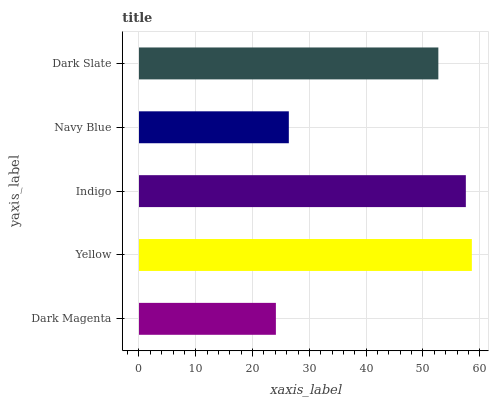Is Dark Magenta the minimum?
Answer yes or no. Yes. Is Yellow the maximum?
Answer yes or no. Yes. Is Indigo the minimum?
Answer yes or no. No. Is Indigo the maximum?
Answer yes or no. No. Is Yellow greater than Indigo?
Answer yes or no. Yes. Is Indigo less than Yellow?
Answer yes or no. Yes. Is Indigo greater than Yellow?
Answer yes or no. No. Is Yellow less than Indigo?
Answer yes or no. No. Is Dark Slate the high median?
Answer yes or no. Yes. Is Dark Slate the low median?
Answer yes or no. Yes. Is Indigo the high median?
Answer yes or no. No. Is Navy Blue the low median?
Answer yes or no. No. 